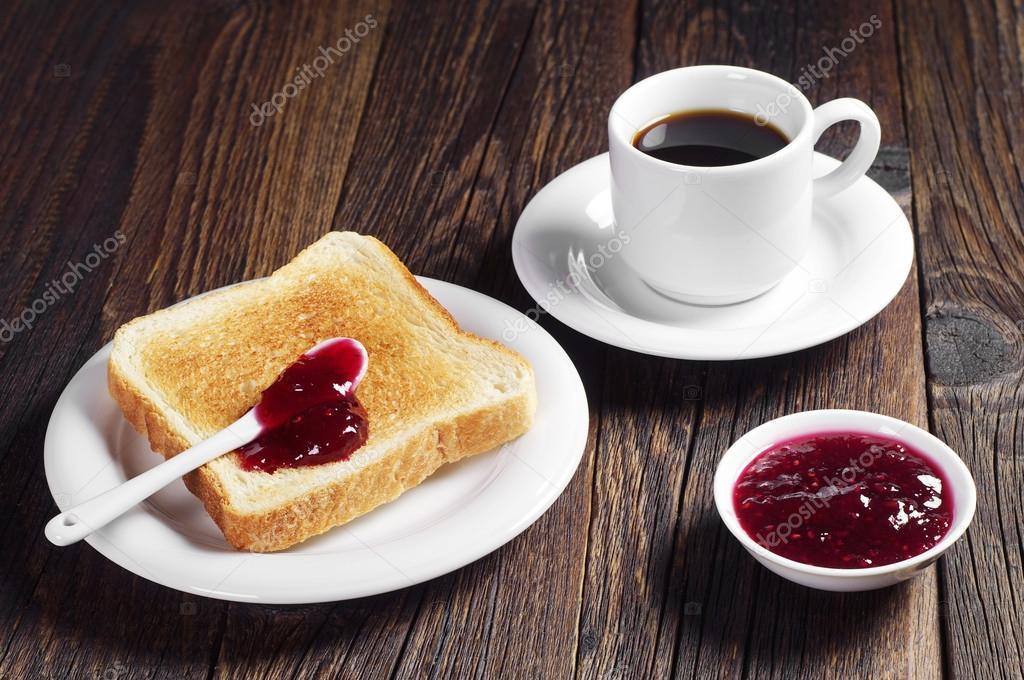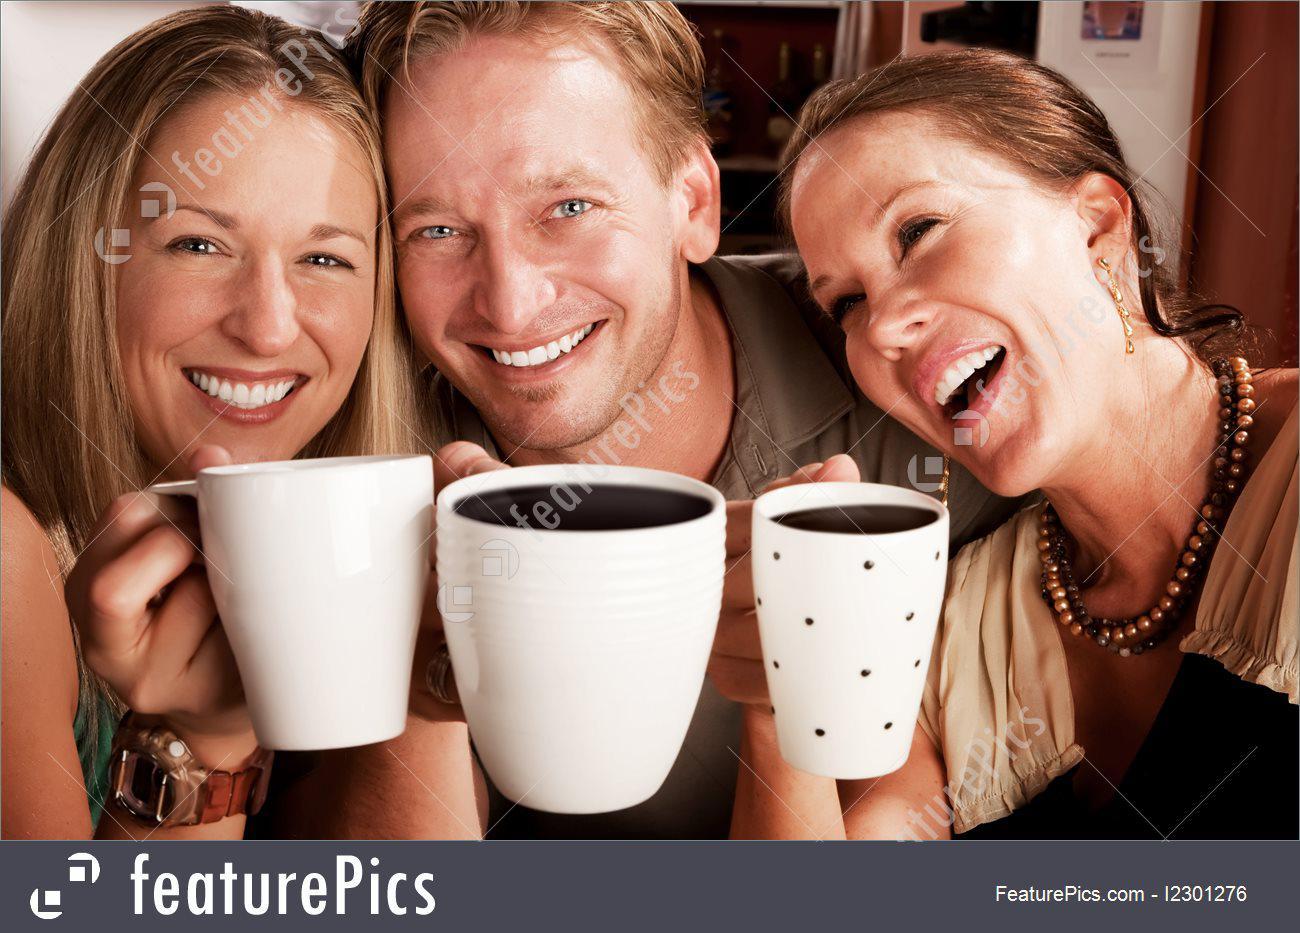The first image is the image on the left, the second image is the image on the right. Considering the images on both sides, is "There are exactly four cups." valid? Answer yes or no. Yes. The first image is the image on the left, the second image is the image on the right. For the images shown, is this caption "At least three people are drinking from mugs together in the image on the right." true? Answer yes or no. Yes. 